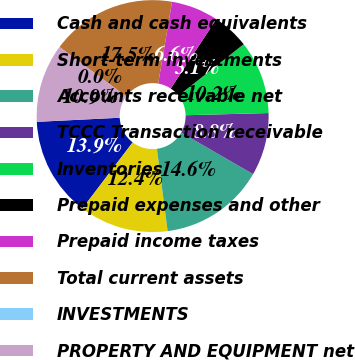Convert chart to OTSL. <chart><loc_0><loc_0><loc_500><loc_500><pie_chart><fcel>Cash and cash equivalents<fcel>Short-term investments<fcel>Accounts receivable net<fcel>TCCC Transaction receivable<fcel>Inventories<fcel>Prepaid expenses and other<fcel>Prepaid income taxes<fcel>Total current assets<fcel>INVESTMENTS<fcel>PROPERTY AND EQUIPMENT net<nl><fcel>13.87%<fcel>12.41%<fcel>14.6%<fcel>8.76%<fcel>10.22%<fcel>5.11%<fcel>6.57%<fcel>17.52%<fcel>0.0%<fcel>10.95%<nl></chart> 